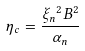<formula> <loc_0><loc_0><loc_500><loc_500>\eta _ { c } = \frac { { \xi _ { n } } ^ { 2 } B ^ { 2 } } { \alpha _ { n } }</formula> 